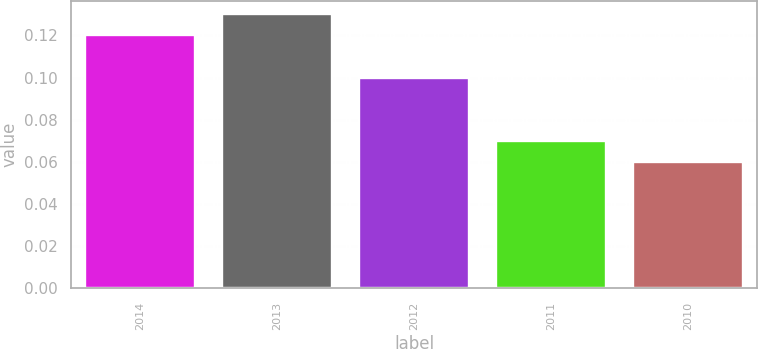Convert chart to OTSL. <chart><loc_0><loc_0><loc_500><loc_500><bar_chart><fcel>2014<fcel>2013<fcel>2012<fcel>2011<fcel>2010<nl><fcel>0.12<fcel>0.13<fcel>0.1<fcel>0.07<fcel>0.06<nl></chart> 